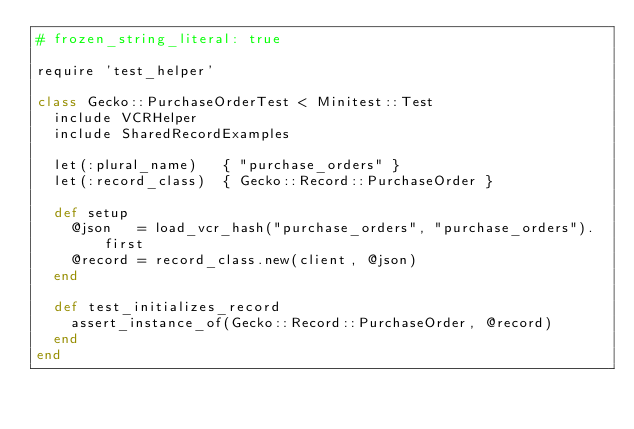Convert code to text. <code><loc_0><loc_0><loc_500><loc_500><_Ruby_># frozen_string_literal: true

require 'test_helper'

class Gecko::PurchaseOrderTest < Minitest::Test
  include VCRHelper
  include SharedRecordExamples

  let(:plural_name)   { "purchase_orders" }
  let(:record_class)  { Gecko::Record::PurchaseOrder }

  def setup
    @json   = load_vcr_hash("purchase_orders", "purchase_orders").first
    @record = record_class.new(client, @json)
  end

  def test_initializes_record
    assert_instance_of(Gecko::Record::PurchaseOrder, @record)
  end
end
</code> 